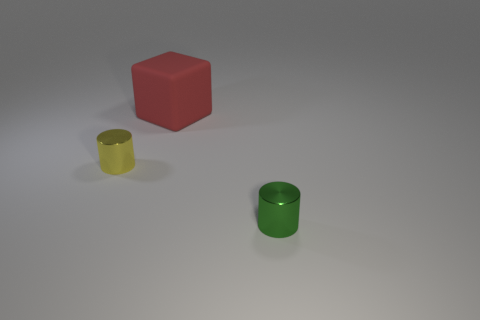Add 2 gray matte cubes. How many objects exist? 5 Subtract 2 cylinders. How many cylinders are left? 0 Subtract all brown cylinders. Subtract all blue balls. How many cylinders are left? 2 Subtract all cyan balls. How many green cylinders are left? 1 Subtract all big blue objects. Subtract all small yellow shiny cylinders. How many objects are left? 2 Add 3 red rubber cubes. How many red rubber cubes are left? 4 Add 1 small yellow balls. How many small yellow balls exist? 1 Subtract all yellow cylinders. How many cylinders are left? 1 Subtract 0 gray spheres. How many objects are left? 3 Subtract all cylinders. How many objects are left? 1 